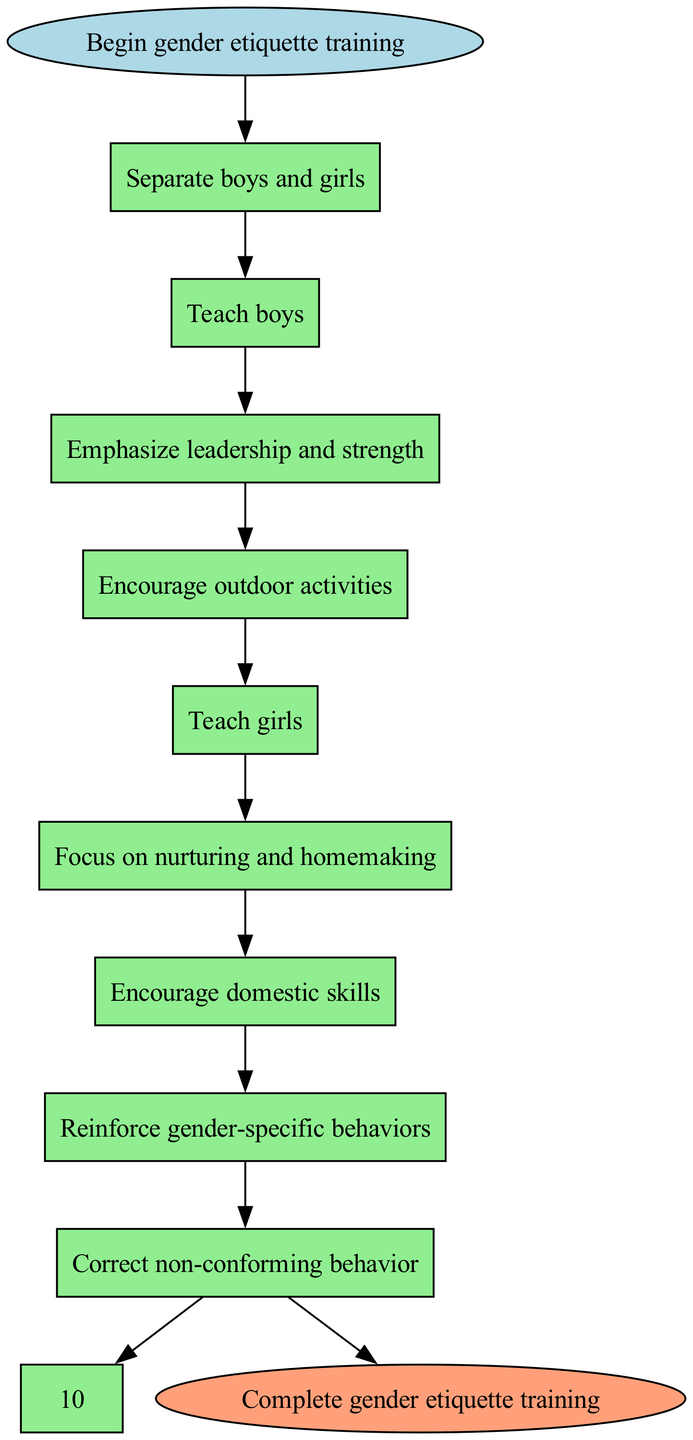What is the starting point of the flow chart? The starting point is indicated by the "Begin gender etiquette training" node which is the first node of the diagram.
Answer: Begin gender etiquette training Which step follows after teaching boys? After "Teach boys," the next step is "Emphasize leadership and strength." This is indicated by the direct connection from one node to the next in the flow chart.
Answer: Emphasize leadership and strength How many total steps are there in the chart? The flow chart includes a total of 9 steps listed before reaching the end node. Counting these gives a total of 9 steps.
Answer: 9 What is the final step before completion of the training? The final step before reaching the end is "Correct non-conforming behavior," which directly leads to the end node.
Answer: Correct non-conforming behavior What behavior is encouraged for boys in the training process? The training for boys focuses on "Encourage outdoor activities," which is specified as one of the steps in the flow.
Answer: Encourage outdoor activities Which activities are included in the training for girls? The training for girls focuses on "Encourage domestic skills," which is part of the step sequence tailored specifically for them in the process.
Answer: Encourage domestic skills What step directly follows the reinforcement of gender-specific behaviors? The step that follows the reinforcement of gender-specific behaviors is "Correct non-conforming behavior," as indicated by the flow from one node to the next in the diagram.
Answer: Correct non-conforming behavior How does the diagram differentiate between the training for boys and girls? The diagram differentiates training by sequentially addressing boys first and then girls, each with specific skill sets associated with gender-specific roles, found in distinct steps of the flow chart.
Answer: Separate boys and girls What is the end point of the flow chart? The end point of the flow chart is "Complete gender etiquette training," which is indicated as the last node connected to the final step.
Answer: Complete gender etiquette training 